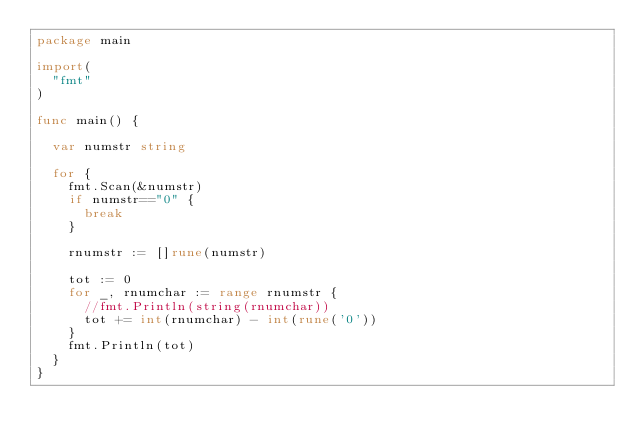<code> <loc_0><loc_0><loc_500><loc_500><_Go_>package main

import(
	"fmt"
)

func main() {

	var numstr string
	
	for {
		fmt.Scan(&numstr)
		if numstr=="0" {
			break
		}

		rnumstr := []rune(numstr)

		tot := 0
		for _, rnumchar := range rnumstr {
			//fmt.Println(string(rnumchar))
			tot += int(rnumchar) - int(rune('0'))
		}
		fmt.Println(tot)
	}
}
</code> 